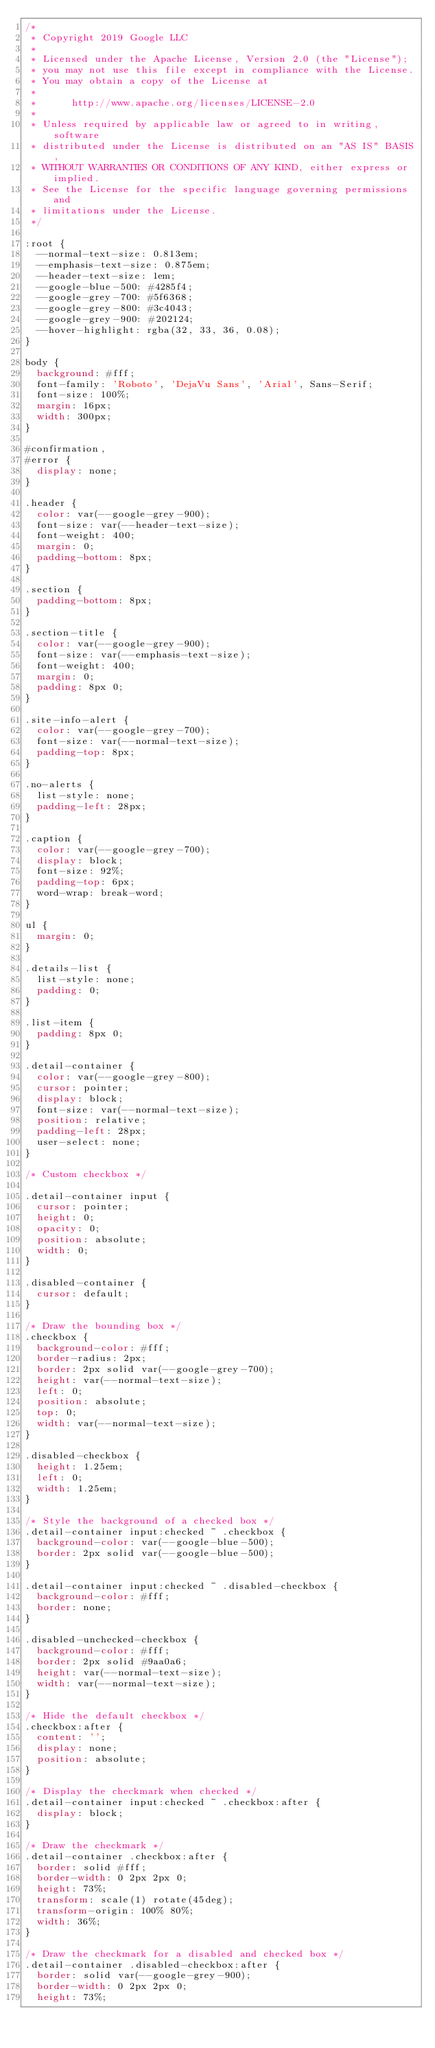<code> <loc_0><loc_0><loc_500><loc_500><_CSS_>/*
 * Copyright 2019 Google LLC
 *
 * Licensed under the Apache License, Version 2.0 (the "License");
 * you may not use this file except in compliance with the License.
 * You may obtain a copy of the License at
 *
 *      http://www.apache.org/licenses/LICENSE-2.0
 *
 * Unless required by applicable law or agreed to in writing, software
 * distributed under the License is distributed on an "AS IS" BASIS,
 * WITHOUT WARRANTIES OR CONDITIONS OF ANY KIND, either express or implied.
 * See the License for the specific language governing permissions and
 * limitations under the License.
 */

:root {
  --normal-text-size: 0.813em;
  --emphasis-text-size: 0.875em;
  --header-text-size: 1em;
  --google-blue-500: #4285f4;
  --google-grey-700: #5f6368;
  --google-grey-800: #3c4043;
  --google-grey-900: #202124;
  --hover-highlight: rgba(32, 33, 36, 0.08);
}

body {
  background: #fff;
  font-family: 'Roboto', 'DejaVu Sans', 'Arial', Sans-Serif;
  font-size: 100%;
  margin: 16px;
  width: 300px;
}

#confirmation,
#error {
  display: none;
}

.header {
  color: var(--google-grey-900);
  font-size: var(--header-text-size);
  font-weight: 400;
  margin: 0;
  padding-bottom: 8px;
}

.section {
  padding-bottom: 8px;
}

.section-title {
  color: var(--google-grey-900);
  font-size: var(--emphasis-text-size);
  font-weight: 400;
  margin: 0;
  padding: 8px 0;
}

.site-info-alert {
  color: var(--google-grey-700);
  font-size: var(--normal-text-size);
  padding-top: 8px;
}

.no-alerts {
  list-style: none;
  padding-left: 28px;
}

.caption {
  color: var(--google-grey-700);
  display: block;
  font-size: 92%;
  padding-top: 6px;
  word-wrap: break-word;
}

ul {
  margin: 0;
}

.details-list {
  list-style: none;
  padding: 0;
}

.list-item {
  padding: 8px 0;
}

.detail-container {
  color: var(--google-grey-800);
  cursor: pointer;
  display: block;
  font-size: var(--normal-text-size);
  position: relative;
  padding-left: 28px;
  user-select: none;
}

/* Custom checkbox */

.detail-container input {
  cursor: pointer;
  height: 0;
  opacity: 0;
  position: absolute;
  width: 0;
}

.disabled-container {
  cursor: default;
}

/* Draw the bounding box */
.checkbox {
  background-color: #fff;
  border-radius: 2px;
  border: 2px solid var(--google-grey-700);
  height: var(--normal-text-size);
  left: 0;
  position: absolute;
  top: 0;
  width: var(--normal-text-size);
}

.disabled-checkbox {
  height: 1.25em;
  left: 0;
  width: 1.25em;
}

/* Style the background of a checked box */
.detail-container input:checked ~ .checkbox {
  background-color: var(--google-blue-500);
  border: 2px solid var(--google-blue-500);
}

.detail-container input:checked ~ .disabled-checkbox {
  background-color: #fff;
  border: none;
}

.disabled-unchecked-checkbox {
  background-color: #fff;
  border: 2px solid #9aa0a6;
  height: var(--normal-text-size);
  width: var(--normal-text-size);
}

/* Hide the default checkbox */
.checkbox:after {
  content: '';
  display: none;
  position: absolute;
}

/* Display the checkmark when checked */
.detail-container input:checked ~ .checkbox:after {
  display: block;
}

/* Draw the checkmark */
.detail-container .checkbox:after {
  border: solid #fff;
  border-width: 0 2px 2px 0;
  height: 73%;
  transform: scale(1) rotate(45deg);
  transform-origin: 100% 80%;
  width: 36%;
}

/* Draw the checkmark for a disabled and checked box */
.detail-container .disabled-checkbox:after {
  border: solid var(--google-grey-900);
  border-width: 0 2px 2px 0;
  height: 73%;</code> 